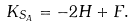<formula> <loc_0><loc_0><loc_500><loc_500>K _ { S _ { A } } = - 2 H + F .</formula> 